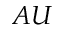<formula> <loc_0><loc_0><loc_500><loc_500>A U</formula> 